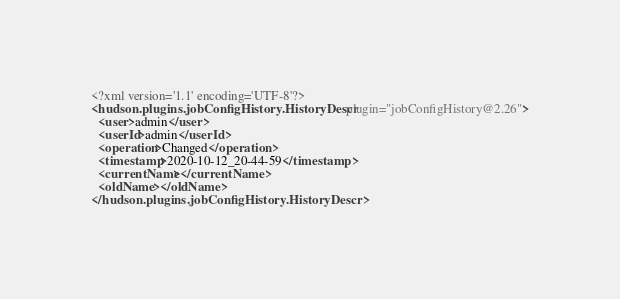Convert code to text. <code><loc_0><loc_0><loc_500><loc_500><_XML_><?xml version='1.1' encoding='UTF-8'?>
<hudson.plugins.jobConfigHistory.HistoryDescr plugin="jobConfigHistory@2.26">
  <user>admin</user>
  <userId>admin</userId>
  <operation>Changed</operation>
  <timestamp>2020-10-12_20-44-59</timestamp>
  <currentName></currentName>
  <oldName></oldName>
</hudson.plugins.jobConfigHistory.HistoryDescr></code> 